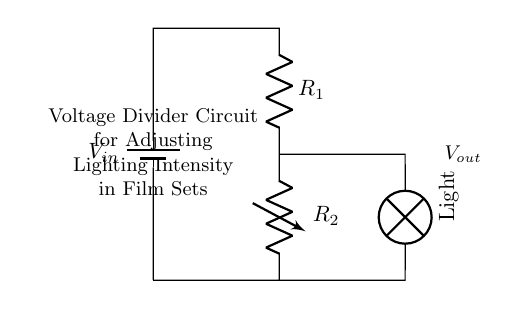What is the input voltage labeled as? The input voltage in the circuit is labeled as V sub in, which represents the source voltage applied to the voltage divider circuit.
Answer: V in What components are used in this circuit? The components in this circuit are a battery, two resistors (one is variable), and a lamp. The battery supplies the voltage, the resistors create the voltage drop, and the lamp is the load that is being controlled.
Answer: Battery, resistors, lamp What kind of resistor is R2? R2 is a variable resistor, also known as a potentiometer, which allows for the adjustment of resistance and thus the light intensity.
Answer: Variable resistor What is the function of the voltage divider? The function of the voltage divider is to adjust the output voltage (V out) based on the resistances R1 and R2, allowing for control of the lighting intensity.
Answer: Adjust lighting intensity How does changing R2 affect the output voltage? Increasing R2 while keeping R1 constant reduces the output voltage V out, as it raises the total resistance of the circuit, leading to a smaller voltage across the lamp. Conversely, decreasing R2 increases V out.
Answer: Decreases output voltage What is the connection type of the components in this circuit? The components in this circuit (battery, resistors, lamp) are connected in series, meaning they are connected end-to-end, allowing for a single path for current flow.
Answer: Series 